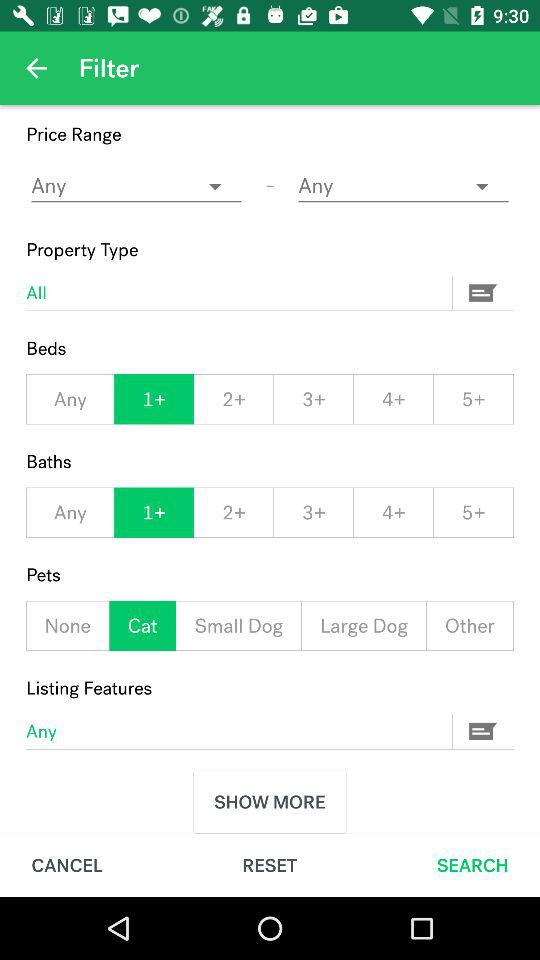What is the selected number of baths? The selected number of baths is more than 1. 